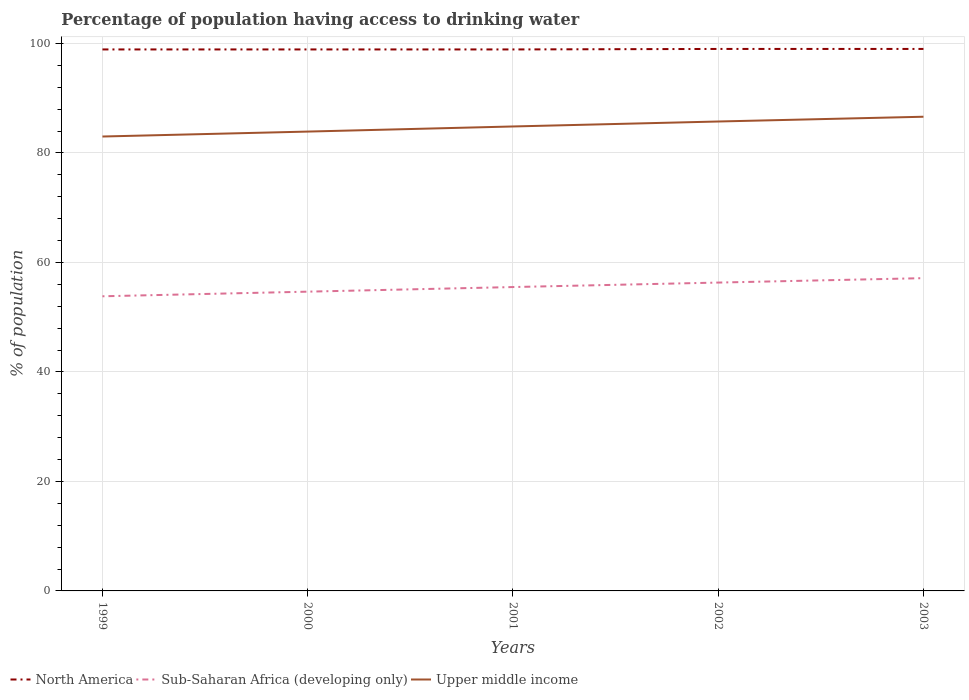How many different coloured lines are there?
Keep it short and to the point. 3. Across all years, what is the maximum percentage of population having access to drinking water in North America?
Provide a short and direct response. 98.9. In which year was the percentage of population having access to drinking water in North America maximum?
Provide a short and direct response. 2000. What is the total percentage of population having access to drinking water in North America in the graph?
Provide a short and direct response. -0. What is the difference between the highest and the second highest percentage of population having access to drinking water in North America?
Make the answer very short. 0.09. What is the difference between the highest and the lowest percentage of population having access to drinking water in Upper middle income?
Provide a succinct answer. 3. Is the percentage of population having access to drinking water in Upper middle income strictly greater than the percentage of population having access to drinking water in Sub-Saharan Africa (developing only) over the years?
Provide a short and direct response. No. What is the difference between two consecutive major ticks on the Y-axis?
Make the answer very short. 20. Are the values on the major ticks of Y-axis written in scientific E-notation?
Offer a very short reply. No. Does the graph contain any zero values?
Offer a terse response. No. Where does the legend appear in the graph?
Your answer should be compact. Bottom left. How many legend labels are there?
Your response must be concise. 3. How are the legend labels stacked?
Offer a very short reply. Horizontal. What is the title of the graph?
Your response must be concise. Percentage of population having access to drinking water. What is the label or title of the Y-axis?
Your answer should be very brief. % of population. What is the % of population of North America in 1999?
Make the answer very short. 98.9. What is the % of population in Sub-Saharan Africa (developing only) in 1999?
Your response must be concise. 53.81. What is the % of population in Upper middle income in 1999?
Ensure brevity in your answer.  82.99. What is the % of population in North America in 2000?
Your response must be concise. 98.9. What is the % of population of Sub-Saharan Africa (developing only) in 2000?
Provide a succinct answer. 54.66. What is the % of population of Upper middle income in 2000?
Make the answer very short. 83.89. What is the % of population in North America in 2001?
Keep it short and to the point. 98.9. What is the % of population of Sub-Saharan Africa (developing only) in 2001?
Provide a succinct answer. 55.5. What is the % of population of Upper middle income in 2001?
Ensure brevity in your answer.  84.83. What is the % of population in North America in 2002?
Provide a short and direct response. 98.99. What is the % of population in Sub-Saharan Africa (developing only) in 2002?
Offer a terse response. 56.32. What is the % of population in Upper middle income in 2002?
Your answer should be compact. 85.74. What is the % of population of North America in 2003?
Offer a terse response. 98.99. What is the % of population in Sub-Saharan Africa (developing only) in 2003?
Give a very brief answer. 57.12. What is the % of population in Upper middle income in 2003?
Offer a terse response. 86.61. Across all years, what is the maximum % of population in North America?
Your answer should be very brief. 98.99. Across all years, what is the maximum % of population of Sub-Saharan Africa (developing only)?
Provide a succinct answer. 57.12. Across all years, what is the maximum % of population in Upper middle income?
Your answer should be very brief. 86.61. Across all years, what is the minimum % of population of North America?
Your response must be concise. 98.9. Across all years, what is the minimum % of population of Sub-Saharan Africa (developing only)?
Give a very brief answer. 53.81. Across all years, what is the minimum % of population of Upper middle income?
Offer a terse response. 82.99. What is the total % of population of North America in the graph?
Ensure brevity in your answer.  494.67. What is the total % of population of Sub-Saharan Africa (developing only) in the graph?
Make the answer very short. 277.42. What is the total % of population in Upper middle income in the graph?
Offer a terse response. 424.06. What is the difference between the % of population in Sub-Saharan Africa (developing only) in 1999 and that in 2000?
Offer a terse response. -0.84. What is the difference between the % of population of Upper middle income in 1999 and that in 2000?
Make the answer very short. -0.9. What is the difference between the % of population in North America in 1999 and that in 2001?
Keep it short and to the point. 0. What is the difference between the % of population of Sub-Saharan Africa (developing only) in 1999 and that in 2001?
Offer a terse response. -1.69. What is the difference between the % of population in Upper middle income in 1999 and that in 2001?
Keep it short and to the point. -1.83. What is the difference between the % of population of North America in 1999 and that in 2002?
Your response must be concise. -0.09. What is the difference between the % of population of Sub-Saharan Africa (developing only) in 1999 and that in 2002?
Provide a short and direct response. -2.5. What is the difference between the % of population in Upper middle income in 1999 and that in 2002?
Offer a terse response. -2.74. What is the difference between the % of population of North America in 1999 and that in 2003?
Offer a terse response. -0.09. What is the difference between the % of population of Sub-Saharan Africa (developing only) in 1999 and that in 2003?
Offer a terse response. -3.31. What is the difference between the % of population of Upper middle income in 1999 and that in 2003?
Give a very brief answer. -3.61. What is the difference between the % of population in North America in 2000 and that in 2001?
Provide a short and direct response. -0. What is the difference between the % of population of Sub-Saharan Africa (developing only) in 2000 and that in 2001?
Provide a succinct answer. -0.84. What is the difference between the % of population of Upper middle income in 2000 and that in 2001?
Your answer should be very brief. -0.93. What is the difference between the % of population of North America in 2000 and that in 2002?
Provide a succinct answer. -0.09. What is the difference between the % of population in Sub-Saharan Africa (developing only) in 2000 and that in 2002?
Your answer should be compact. -1.66. What is the difference between the % of population of Upper middle income in 2000 and that in 2002?
Give a very brief answer. -1.84. What is the difference between the % of population of North America in 2000 and that in 2003?
Ensure brevity in your answer.  -0.09. What is the difference between the % of population in Sub-Saharan Africa (developing only) in 2000 and that in 2003?
Provide a succinct answer. -2.47. What is the difference between the % of population in Upper middle income in 2000 and that in 2003?
Ensure brevity in your answer.  -2.71. What is the difference between the % of population in North America in 2001 and that in 2002?
Offer a very short reply. -0.09. What is the difference between the % of population of Sub-Saharan Africa (developing only) in 2001 and that in 2002?
Offer a terse response. -0.82. What is the difference between the % of population of Upper middle income in 2001 and that in 2002?
Offer a terse response. -0.91. What is the difference between the % of population of North America in 2001 and that in 2003?
Make the answer very short. -0.09. What is the difference between the % of population in Sub-Saharan Africa (developing only) in 2001 and that in 2003?
Your answer should be compact. -1.63. What is the difference between the % of population in Upper middle income in 2001 and that in 2003?
Offer a very short reply. -1.78. What is the difference between the % of population of North America in 2002 and that in 2003?
Give a very brief answer. -0. What is the difference between the % of population of Sub-Saharan Africa (developing only) in 2002 and that in 2003?
Provide a succinct answer. -0.81. What is the difference between the % of population of Upper middle income in 2002 and that in 2003?
Provide a short and direct response. -0.87. What is the difference between the % of population in North America in 1999 and the % of population in Sub-Saharan Africa (developing only) in 2000?
Your response must be concise. 44.24. What is the difference between the % of population of North America in 1999 and the % of population of Upper middle income in 2000?
Offer a very short reply. 15. What is the difference between the % of population in Sub-Saharan Africa (developing only) in 1999 and the % of population in Upper middle income in 2000?
Offer a terse response. -30.08. What is the difference between the % of population of North America in 1999 and the % of population of Sub-Saharan Africa (developing only) in 2001?
Keep it short and to the point. 43.4. What is the difference between the % of population of North America in 1999 and the % of population of Upper middle income in 2001?
Make the answer very short. 14.07. What is the difference between the % of population of Sub-Saharan Africa (developing only) in 1999 and the % of population of Upper middle income in 2001?
Give a very brief answer. -31.01. What is the difference between the % of population of North America in 1999 and the % of population of Sub-Saharan Africa (developing only) in 2002?
Provide a short and direct response. 42.58. What is the difference between the % of population in North America in 1999 and the % of population in Upper middle income in 2002?
Your answer should be compact. 13.16. What is the difference between the % of population in Sub-Saharan Africa (developing only) in 1999 and the % of population in Upper middle income in 2002?
Provide a succinct answer. -31.92. What is the difference between the % of population in North America in 1999 and the % of population in Sub-Saharan Africa (developing only) in 2003?
Your answer should be very brief. 41.77. What is the difference between the % of population of North America in 1999 and the % of population of Upper middle income in 2003?
Your response must be concise. 12.29. What is the difference between the % of population of Sub-Saharan Africa (developing only) in 1999 and the % of population of Upper middle income in 2003?
Keep it short and to the point. -32.79. What is the difference between the % of population in North America in 2000 and the % of population in Sub-Saharan Africa (developing only) in 2001?
Your answer should be very brief. 43.4. What is the difference between the % of population of North America in 2000 and the % of population of Upper middle income in 2001?
Make the answer very short. 14.07. What is the difference between the % of population of Sub-Saharan Africa (developing only) in 2000 and the % of population of Upper middle income in 2001?
Provide a succinct answer. -30.17. What is the difference between the % of population of North America in 2000 and the % of population of Sub-Saharan Africa (developing only) in 2002?
Offer a terse response. 42.58. What is the difference between the % of population of North America in 2000 and the % of population of Upper middle income in 2002?
Offer a terse response. 13.16. What is the difference between the % of population in Sub-Saharan Africa (developing only) in 2000 and the % of population in Upper middle income in 2002?
Keep it short and to the point. -31.08. What is the difference between the % of population in North America in 2000 and the % of population in Sub-Saharan Africa (developing only) in 2003?
Provide a short and direct response. 41.77. What is the difference between the % of population of North America in 2000 and the % of population of Upper middle income in 2003?
Make the answer very short. 12.29. What is the difference between the % of population of Sub-Saharan Africa (developing only) in 2000 and the % of population of Upper middle income in 2003?
Offer a very short reply. -31.95. What is the difference between the % of population of North America in 2001 and the % of population of Sub-Saharan Africa (developing only) in 2002?
Offer a terse response. 42.58. What is the difference between the % of population in North America in 2001 and the % of population in Upper middle income in 2002?
Make the answer very short. 13.16. What is the difference between the % of population in Sub-Saharan Africa (developing only) in 2001 and the % of population in Upper middle income in 2002?
Make the answer very short. -30.24. What is the difference between the % of population in North America in 2001 and the % of population in Sub-Saharan Africa (developing only) in 2003?
Ensure brevity in your answer.  41.77. What is the difference between the % of population of North America in 2001 and the % of population of Upper middle income in 2003?
Your answer should be compact. 12.29. What is the difference between the % of population of Sub-Saharan Africa (developing only) in 2001 and the % of population of Upper middle income in 2003?
Your answer should be compact. -31.11. What is the difference between the % of population in North America in 2002 and the % of population in Sub-Saharan Africa (developing only) in 2003?
Your answer should be compact. 41.86. What is the difference between the % of population of North America in 2002 and the % of population of Upper middle income in 2003?
Make the answer very short. 12.38. What is the difference between the % of population in Sub-Saharan Africa (developing only) in 2002 and the % of population in Upper middle income in 2003?
Make the answer very short. -30.29. What is the average % of population of North America per year?
Offer a very short reply. 98.93. What is the average % of population in Sub-Saharan Africa (developing only) per year?
Offer a terse response. 55.48. What is the average % of population in Upper middle income per year?
Provide a short and direct response. 84.81. In the year 1999, what is the difference between the % of population in North America and % of population in Sub-Saharan Africa (developing only)?
Ensure brevity in your answer.  45.08. In the year 1999, what is the difference between the % of population in North America and % of population in Upper middle income?
Your answer should be very brief. 15.9. In the year 1999, what is the difference between the % of population in Sub-Saharan Africa (developing only) and % of population in Upper middle income?
Your answer should be compact. -29.18. In the year 2000, what is the difference between the % of population of North America and % of population of Sub-Saharan Africa (developing only)?
Make the answer very short. 44.24. In the year 2000, what is the difference between the % of population of North America and % of population of Upper middle income?
Offer a very short reply. 15. In the year 2000, what is the difference between the % of population in Sub-Saharan Africa (developing only) and % of population in Upper middle income?
Provide a short and direct response. -29.24. In the year 2001, what is the difference between the % of population of North America and % of population of Sub-Saharan Africa (developing only)?
Keep it short and to the point. 43.4. In the year 2001, what is the difference between the % of population in North America and % of population in Upper middle income?
Provide a short and direct response. 14.07. In the year 2001, what is the difference between the % of population in Sub-Saharan Africa (developing only) and % of population in Upper middle income?
Ensure brevity in your answer.  -29.33. In the year 2002, what is the difference between the % of population in North America and % of population in Sub-Saharan Africa (developing only)?
Make the answer very short. 42.67. In the year 2002, what is the difference between the % of population in North America and % of population in Upper middle income?
Your response must be concise. 13.25. In the year 2002, what is the difference between the % of population of Sub-Saharan Africa (developing only) and % of population of Upper middle income?
Provide a short and direct response. -29.42. In the year 2003, what is the difference between the % of population in North America and % of population in Sub-Saharan Africa (developing only)?
Offer a terse response. 41.86. In the year 2003, what is the difference between the % of population in North America and % of population in Upper middle income?
Offer a very short reply. 12.38. In the year 2003, what is the difference between the % of population of Sub-Saharan Africa (developing only) and % of population of Upper middle income?
Give a very brief answer. -29.48. What is the ratio of the % of population in North America in 1999 to that in 2000?
Provide a short and direct response. 1. What is the ratio of the % of population of Sub-Saharan Africa (developing only) in 1999 to that in 2000?
Offer a very short reply. 0.98. What is the ratio of the % of population of Upper middle income in 1999 to that in 2000?
Your answer should be compact. 0.99. What is the ratio of the % of population in Sub-Saharan Africa (developing only) in 1999 to that in 2001?
Your response must be concise. 0.97. What is the ratio of the % of population in Upper middle income in 1999 to that in 2001?
Provide a short and direct response. 0.98. What is the ratio of the % of population in North America in 1999 to that in 2002?
Give a very brief answer. 1. What is the ratio of the % of population of Sub-Saharan Africa (developing only) in 1999 to that in 2002?
Give a very brief answer. 0.96. What is the ratio of the % of population in Sub-Saharan Africa (developing only) in 1999 to that in 2003?
Your answer should be very brief. 0.94. What is the ratio of the % of population of Upper middle income in 1999 to that in 2003?
Your answer should be very brief. 0.96. What is the ratio of the % of population in North America in 2000 to that in 2001?
Ensure brevity in your answer.  1. What is the ratio of the % of population of Sub-Saharan Africa (developing only) in 2000 to that in 2001?
Your response must be concise. 0.98. What is the ratio of the % of population of Upper middle income in 2000 to that in 2001?
Offer a terse response. 0.99. What is the ratio of the % of population of North America in 2000 to that in 2002?
Keep it short and to the point. 1. What is the ratio of the % of population in Sub-Saharan Africa (developing only) in 2000 to that in 2002?
Keep it short and to the point. 0.97. What is the ratio of the % of population of Upper middle income in 2000 to that in 2002?
Provide a succinct answer. 0.98. What is the ratio of the % of population in Sub-Saharan Africa (developing only) in 2000 to that in 2003?
Give a very brief answer. 0.96. What is the ratio of the % of population of Upper middle income in 2000 to that in 2003?
Ensure brevity in your answer.  0.97. What is the ratio of the % of population of Sub-Saharan Africa (developing only) in 2001 to that in 2002?
Offer a very short reply. 0.99. What is the ratio of the % of population in North America in 2001 to that in 2003?
Ensure brevity in your answer.  1. What is the ratio of the % of population of Sub-Saharan Africa (developing only) in 2001 to that in 2003?
Ensure brevity in your answer.  0.97. What is the ratio of the % of population in Upper middle income in 2001 to that in 2003?
Your answer should be very brief. 0.98. What is the ratio of the % of population in North America in 2002 to that in 2003?
Offer a terse response. 1. What is the ratio of the % of population in Sub-Saharan Africa (developing only) in 2002 to that in 2003?
Your response must be concise. 0.99. What is the ratio of the % of population in Upper middle income in 2002 to that in 2003?
Provide a short and direct response. 0.99. What is the difference between the highest and the second highest % of population of North America?
Provide a succinct answer. 0. What is the difference between the highest and the second highest % of population in Sub-Saharan Africa (developing only)?
Ensure brevity in your answer.  0.81. What is the difference between the highest and the second highest % of population in Upper middle income?
Your response must be concise. 0.87. What is the difference between the highest and the lowest % of population in North America?
Ensure brevity in your answer.  0.09. What is the difference between the highest and the lowest % of population of Sub-Saharan Africa (developing only)?
Your response must be concise. 3.31. What is the difference between the highest and the lowest % of population in Upper middle income?
Your answer should be very brief. 3.61. 